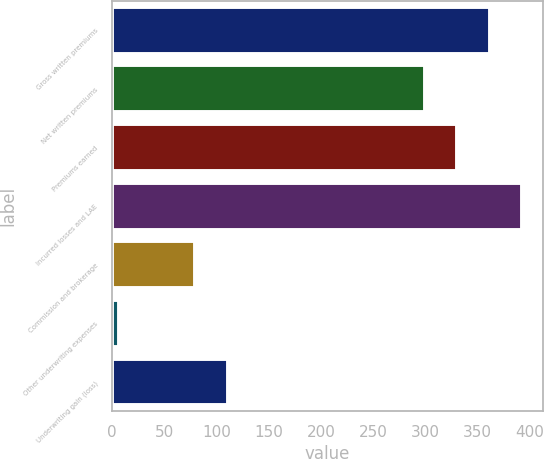Convert chart. <chart><loc_0><loc_0><loc_500><loc_500><bar_chart><fcel>Gross written premiums<fcel>Net written premiums<fcel>Premiums earned<fcel>Incurred losses and LAE<fcel>Commission and brokerage<fcel>Other underwriting expenses<fcel>Underwriting gain (loss)<nl><fcel>361.52<fcel>299.3<fcel>330.41<fcel>392.63<fcel>79.7<fcel>6.8<fcel>110.81<nl></chart> 